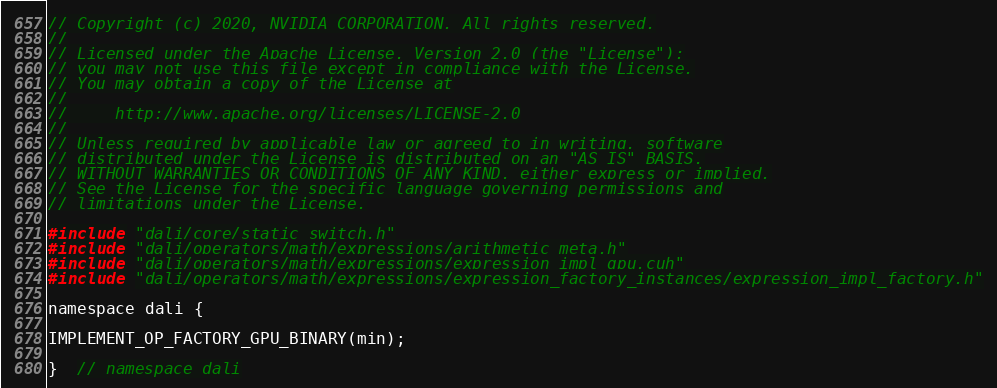Convert code to text. <code><loc_0><loc_0><loc_500><loc_500><_Cuda_>// Copyright (c) 2020, NVIDIA CORPORATION. All rights reserved.
//
// Licensed under the Apache License, Version 2.0 (the "License");
// you may not use this file except in compliance with the License.
// You may obtain a copy of the License at
//
//     http://www.apache.org/licenses/LICENSE-2.0
//
// Unless required by applicable law or agreed to in writing, software
// distributed under the License is distributed on an "AS IS" BASIS,
// WITHOUT WARRANTIES OR CONDITIONS OF ANY KIND, either express or implied.
// See the License for the specific language governing permissions and
// limitations under the License.

#include "dali/core/static_switch.h"
#include "dali/operators/math/expressions/arithmetic_meta.h"
#include "dali/operators/math/expressions/expression_impl_gpu.cuh"
#include "dali/operators/math/expressions/expression_factory_instances/expression_impl_factory.h"

namespace dali {

IMPLEMENT_OP_FACTORY_GPU_BINARY(min);

}  // namespace dali
</code> 